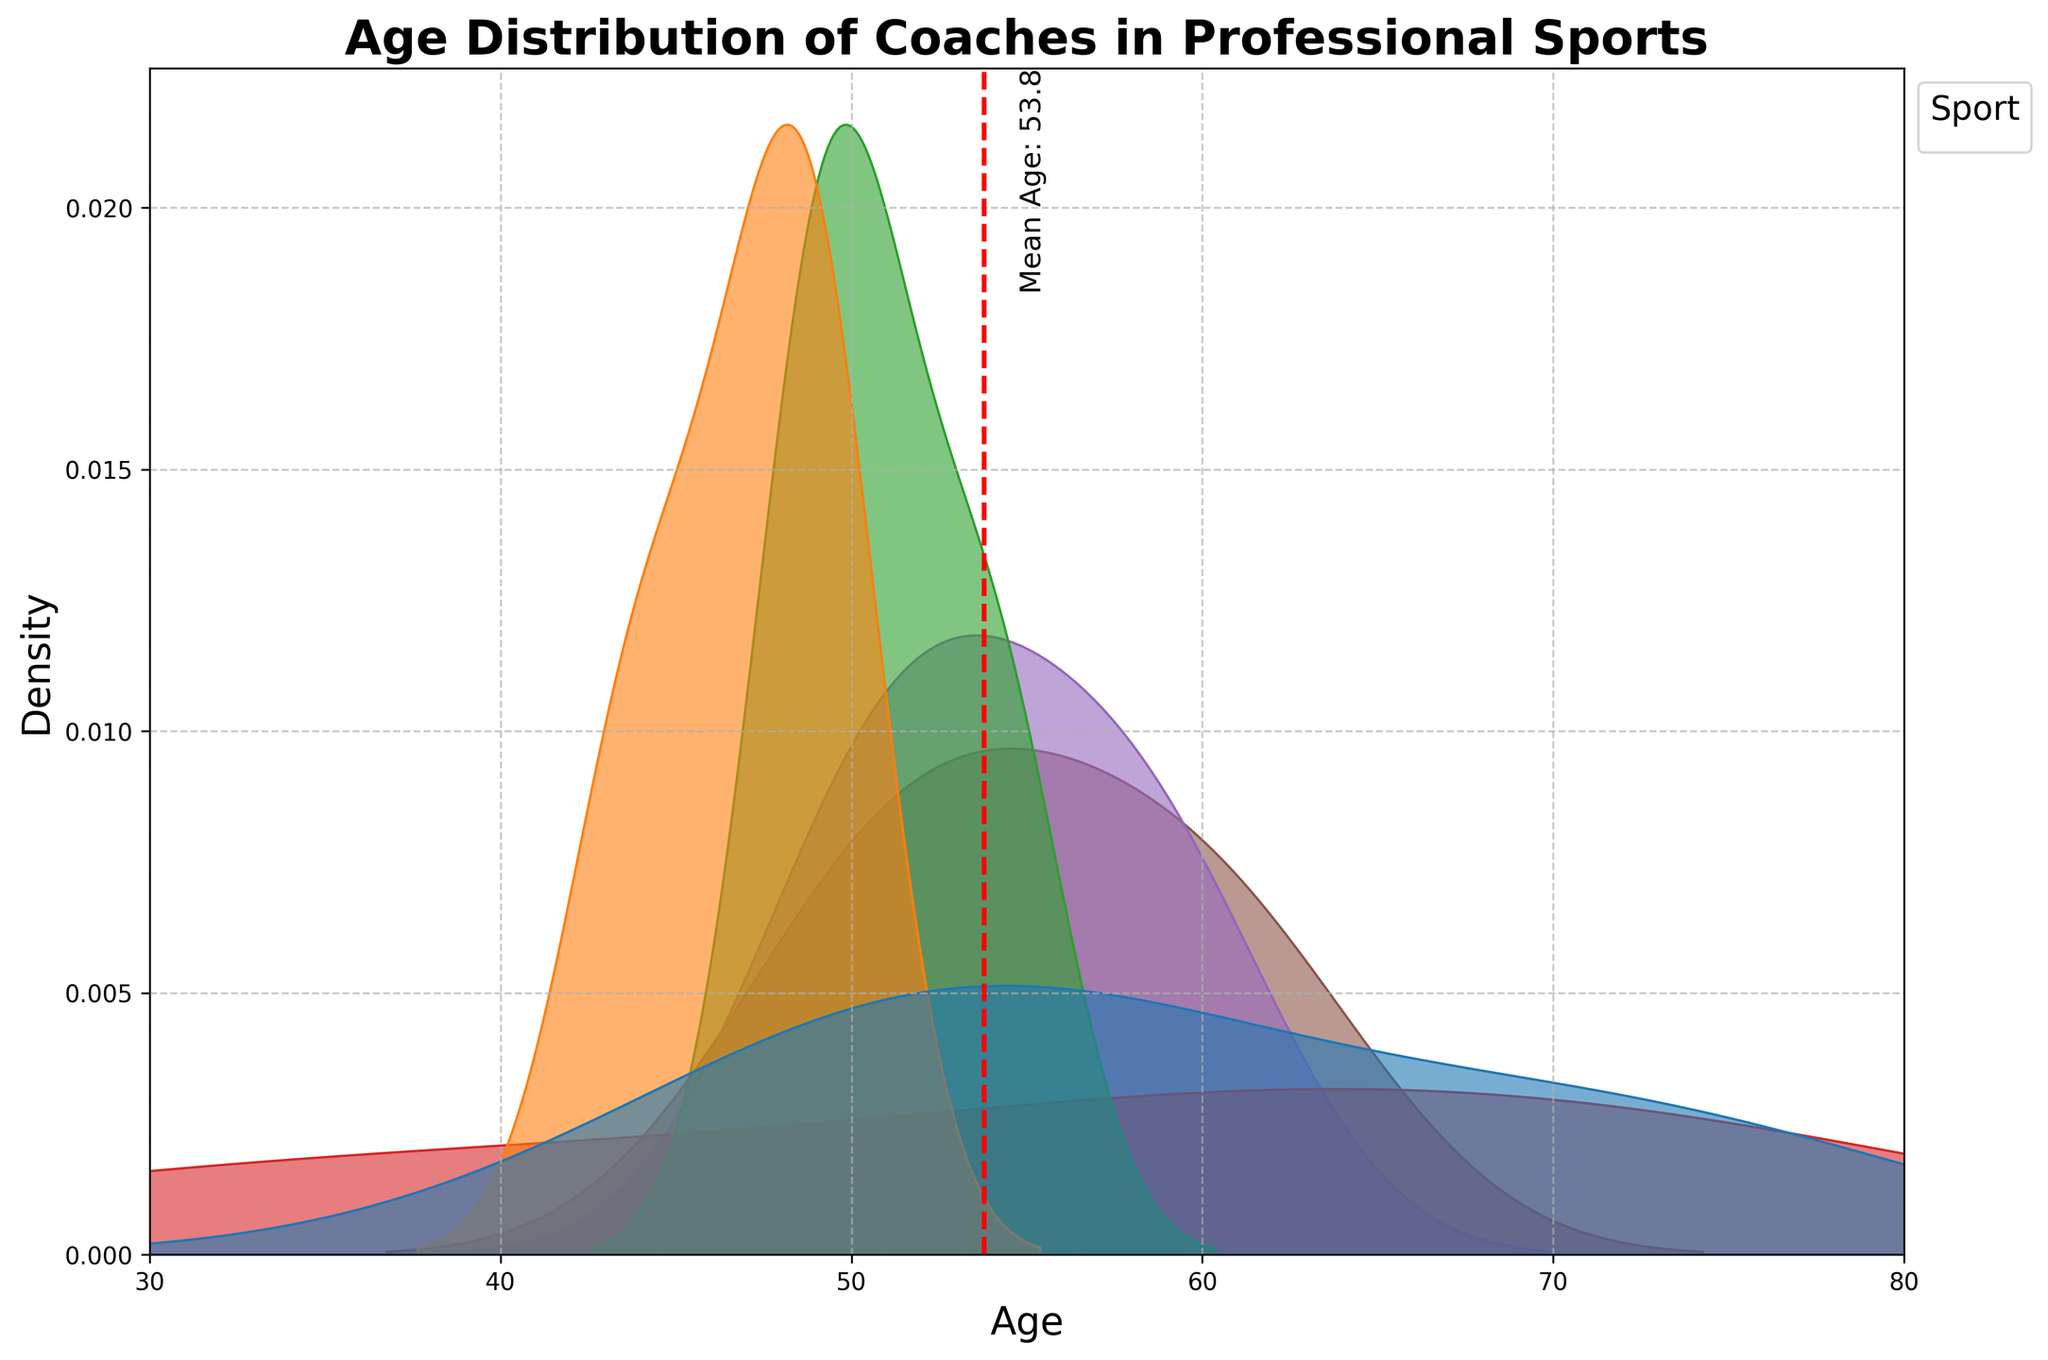What's the title of the plot? The title is located at the top of the plot in larger, bold text. It represents the main topic of the visualization.
Answer: Age Distribution of Coaches in Professional Sports What is the age range of the coaches displayed in the plot? The age range can be determined by looking at the x-axis, which is labeled 'Age'. The plot depicts data from ages 30 to 80.
Answer: 30 to 80 Which sport has the highest density of younger coaches (around the age of 40)? The density of younger coaches can be identified via the peaks of the density curves around age 40. Based on this, it appears that Baseball has the highest density around this age.
Answer: Baseball Where is the mean age indicated on the plot? The mean age is marked by a vertical dashed red line and labeled 'Mean Age: [mean value]' in text. It crosses the x-axis at this point.
Answer: Near 53.7 Which sports have a noticeable peak between ages 55-60? To determine this, look for the peaks in the density curves within the age range of 55-60. Football and Basketball both show noticeable peaks in this range.
Answer: Football, Basketball Are there more coaches aged over 60 in Football or Tennis? By comparing the density of the curves beyond age 60 for Football and Tennis, Football shows a higher density, indicating more coaches in that age range.
Answer: Football Do any sports have a higher density of coaches around the age of 50? To identify this, look at which sport's density curve peaks or remains higher around age 50. Both Soccer and Tennis show higher densities around the age of 50.
Answer: Soccer, Tennis What feature helps easily determine the density differences between the sports? The color and shading of the density curves help identify the density differences. Each sport has a different curve with varying heights and shades, making the comparison visually straightforward.
Answer: Color and shading Which sports have their density curves closely overlapping, indicating similar age distributions? Look for areas where the density curves of different sports overlap each other closely. Soccer and Tennis have overlapping curves, indicating similar age distributions.
Answer: Soccer, Tennis Is there a wider age distribution in Hockey compared to Soccer? Comparing the span of the density curves from left to right, Soccer's curve is narrower whereas Hockey's curve spans a wider range on the x-axis.
Answer: Yes 